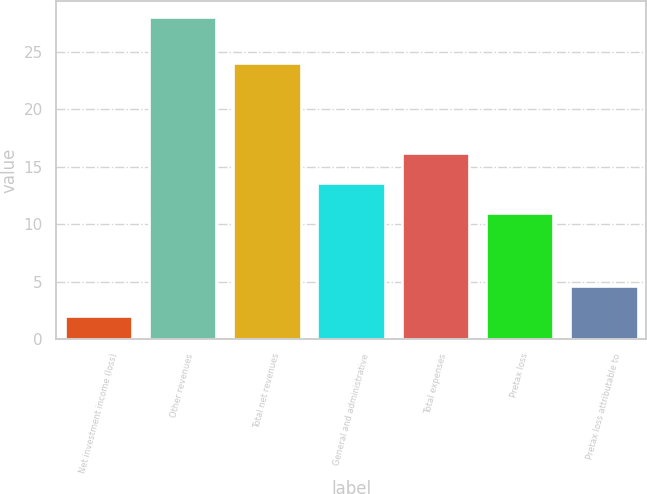<chart> <loc_0><loc_0><loc_500><loc_500><bar_chart><fcel>Net investment income (loss)<fcel>Other revenues<fcel>Total net revenues<fcel>General and administrative<fcel>Total expenses<fcel>Pretax loss<fcel>Pretax loss attributable to<nl><fcel>2<fcel>28<fcel>24<fcel>13.6<fcel>16.2<fcel>11<fcel>4.6<nl></chart> 